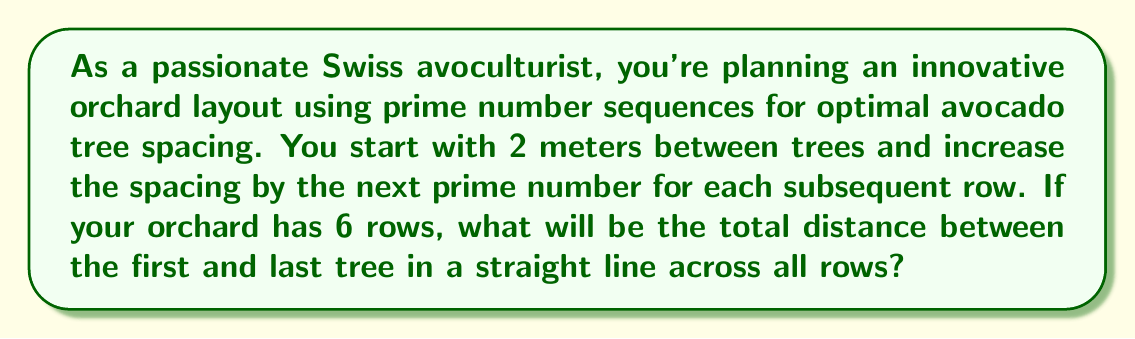Teach me how to tackle this problem. Let's approach this step-by-step:

1) First, we need to identify the prime number sequence for the 6 rows:
   2, 3, 5, 7, 11, 13

2) Now, let's calculate the spacing for each row:
   Row 1: 2 meters
   Row 2: 2 + 3 = 5 meters
   Row 3: 5 + 5 = 10 meters
   Row 4: 10 + 7 = 17 meters
   Row 5: 17 + 11 = 28 meters
   Row 6: 28 + 13 = 41 meters

3) To find the total distance, we need to sum up all these spacings:

   $$\text{Total Distance} = 2 + 3 + 5 + 7 + 11 + 13$$

4) Let's calculate:
   $$2 + 3 + 5 + 7 + 11 + 13 = 41$$

Therefore, the total distance between the first and last tree in a straight line across all 6 rows is 41 meters.
Answer: 41 meters 